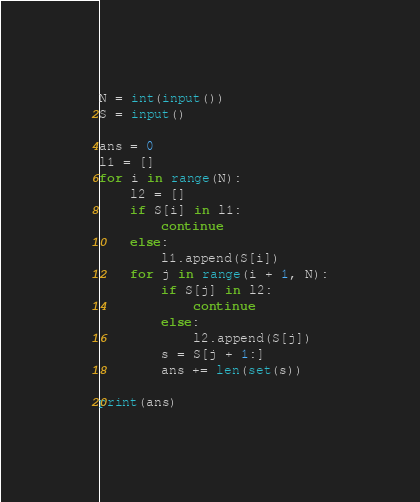<code> <loc_0><loc_0><loc_500><loc_500><_Python_>N = int(input())
S = input()

ans = 0
l1 = []
for i in range(N):
    l2 = []
    if S[i] in l1:
        continue
    else:
        l1.append(S[i])
    for j in range(i + 1, N):
        if S[j] in l2:
            continue
        else:
            l2.append(S[j])
        s = S[j + 1:]
        ans += len(set(s))

print(ans)
</code> 